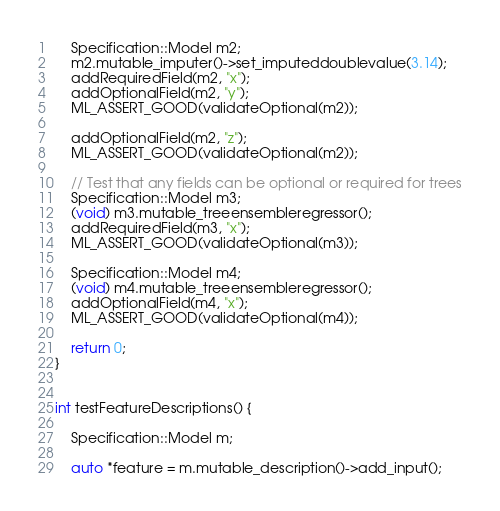Convert code to text. <code><loc_0><loc_0><loc_500><loc_500><_C++_>    Specification::Model m2;
    m2.mutable_imputer()->set_imputeddoublevalue(3.14);
    addRequiredField(m2, "x");
    addOptionalField(m2, "y");
    ML_ASSERT_GOOD(validateOptional(m2));

    addOptionalField(m2, "z");
    ML_ASSERT_GOOD(validateOptional(m2));

    // Test that any fields can be optional or required for trees
    Specification::Model m3;
    (void) m3.mutable_treeensembleregressor();
    addRequiredField(m3, "x");
    ML_ASSERT_GOOD(validateOptional(m3));

    Specification::Model m4;
    (void) m4.mutable_treeensembleregressor();
    addOptionalField(m4, "x");
    ML_ASSERT_GOOD(validateOptional(m4));

    return 0;
}


int testFeatureDescriptions() {

    Specification::Model m;

    auto *feature = m.mutable_description()->add_input();</code> 